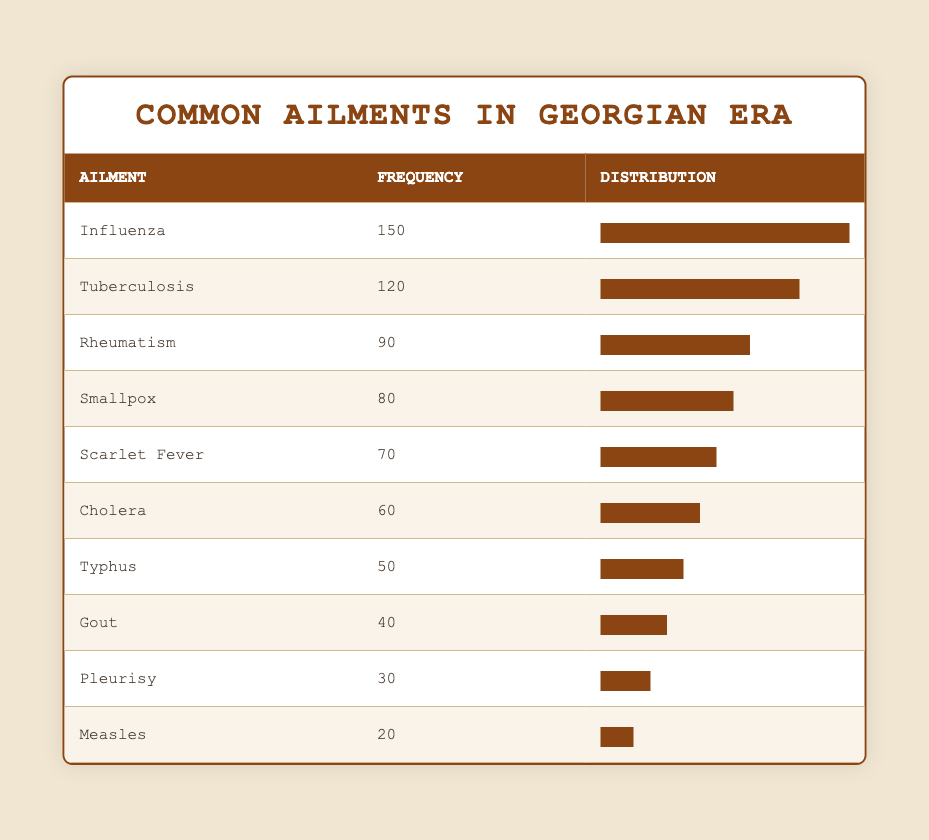What is the most common ailment reported in the Georgian medical records? The table shows the frequency of common ailments. Influenza has the highest frequency at 150, making it the most common ailment.
Answer: Influenza How many cases of tuberculosis were reported? From the table, tuberculosis is listed with a frequency of 120 cases.
Answer: 120 Which ailment has the lowest reported frequency? According to the table, measles has the lowest reported frequency at 20 cases.
Answer: Measles What is the total frequency of all ailments listed in the table? To find the total frequency, sum the frequencies of all ailments: 150 + 120 + 90 + 80 + 70 + 60 + 50 + 40 + 30 + 20 = 800.
Answer: 800 Is the frequency of smallpox greater than that of scarlet fever? The table shows smallpox has a frequency of 80 and scarlet fever has 70. Since 80 is greater than 70, the statement is true.
Answer: Yes What percentage of the total reported cases does influenza represent? Total frequency is 800. Influenza has 150 cases. To calculate the percentage, (150 / 800) * 100 = 18.75%.
Answer: 18.75% What are the frequency differences between tuberculosis and rheumatism? Tuberculosis has a frequency of 120 and rheumatism has 90. The difference is 120 - 90 = 30.
Answer: 30 If we combine the frequencies of cholera and typhus, what do we get? Cholera has a frequency of 60 and typhus has 50. Adding these frequencies together gives us 60 + 50 = 110.
Answer: 110 Are there more cases of rheumatism than gout? Rheumatism has a frequency of 90, while gout has 40. Since 90 is greater than 40, the statement is true.
Answer: Yes 